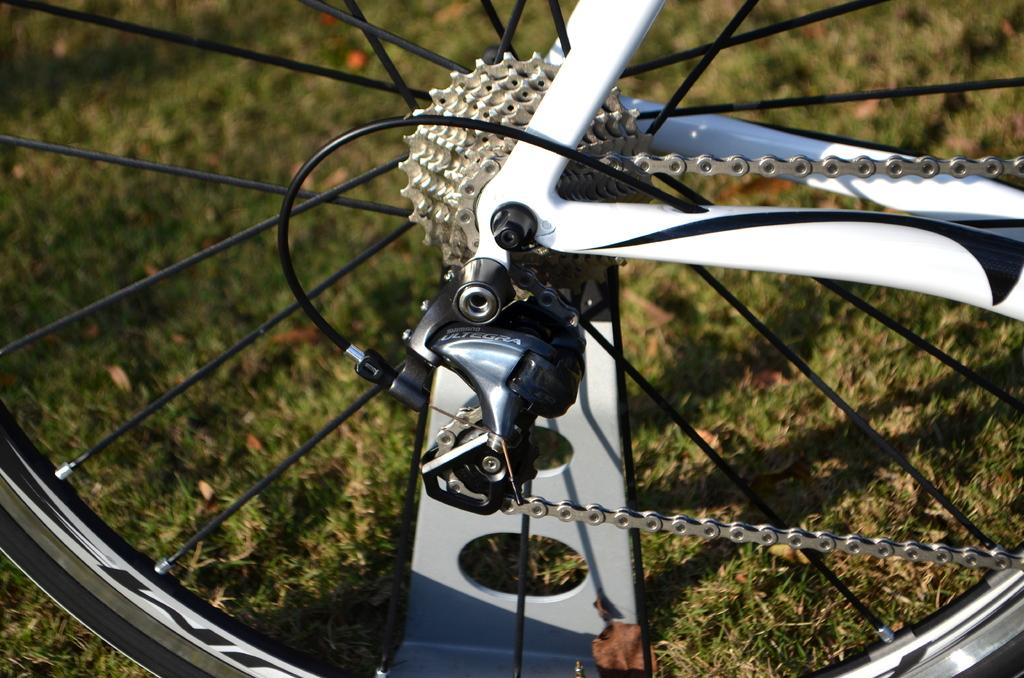What is the main subject of the image? The main subject of the image is parts of a bicycle wheel. Can you describe the background of the image? The background of the image includes grass. How many divisions are present in the image? There is no mention of divisions in the image, as it only features parts of a bicycle wheel and grass in the background. Are there any horses visible in the image? No, there are no horses present in the image. 